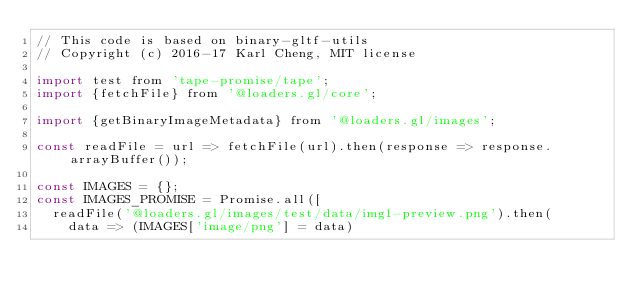Convert code to text. <code><loc_0><loc_0><loc_500><loc_500><_JavaScript_>// This code is based on binary-gltf-utils
// Copyright (c) 2016-17 Karl Cheng, MIT license

import test from 'tape-promise/tape';
import {fetchFile} from '@loaders.gl/core';

import {getBinaryImageMetadata} from '@loaders.gl/images';

const readFile = url => fetchFile(url).then(response => response.arrayBuffer());

const IMAGES = {};
const IMAGES_PROMISE = Promise.all([
  readFile('@loaders.gl/images/test/data/img1-preview.png').then(
    data => (IMAGES['image/png'] = data)</code> 